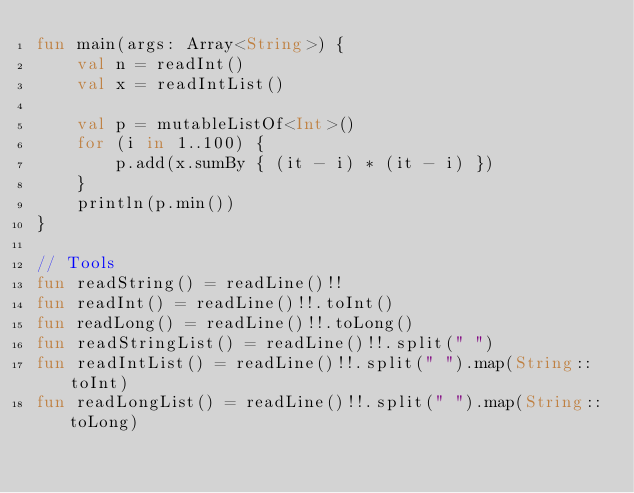<code> <loc_0><loc_0><loc_500><loc_500><_Kotlin_>fun main(args: Array<String>) {
    val n = readInt()
    val x = readIntList()

    val p = mutableListOf<Int>()
    for (i in 1..100) {
        p.add(x.sumBy { (it - i) * (it - i) })
    }
    println(p.min())
}

// Tools
fun readString() = readLine()!!
fun readInt() = readLine()!!.toInt()
fun readLong() = readLine()!!.toLong()
fun readStringList() = readLine()!!.split(" ")
fun readIntList() = readLine()!!.split(" ").map(String::toInt)
fun readLongList() = readLine()!!.split(" ").map(String::toLong)</code> 